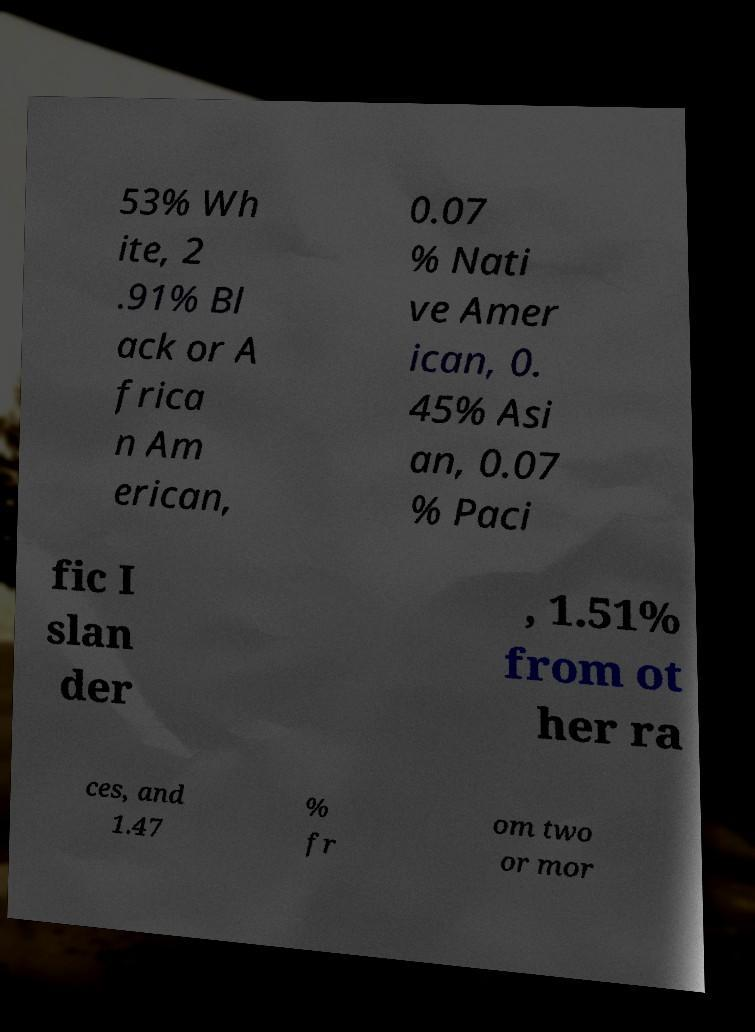I need the written content from this picture converted into text. Can you do that? 53% Wh ite, 2 .91% Bl ack or A frica n Am erican, 0.07 % Nati ve Amer ican, 0. 45% Asi an, 0.07 % Paci fic I slan der , 1.51% from ot her ra ces, and 1.47 % fr om two or mor 